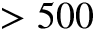Convert formula to latex. <formula><loc_0><loc_0><loc_500><loc_500>> 5 0 0</formula> 